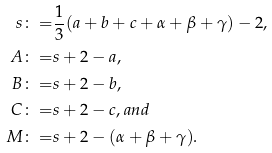<formula> <loc_0><loc_0><loc_500><loc_500>s \colon = & \frac { 1 } { 3 } ( a + b + c + \alpha + \beta + \gamma ) - 2 , \\ A \colon = & s + 2 - a , \\ B \colon = & s + 2 - b , \\ C \colon = & s + 2 - c , a n d \\ M \colon = & s + 2 - ( \alpha + \beta + \gamma ) .</formula> 